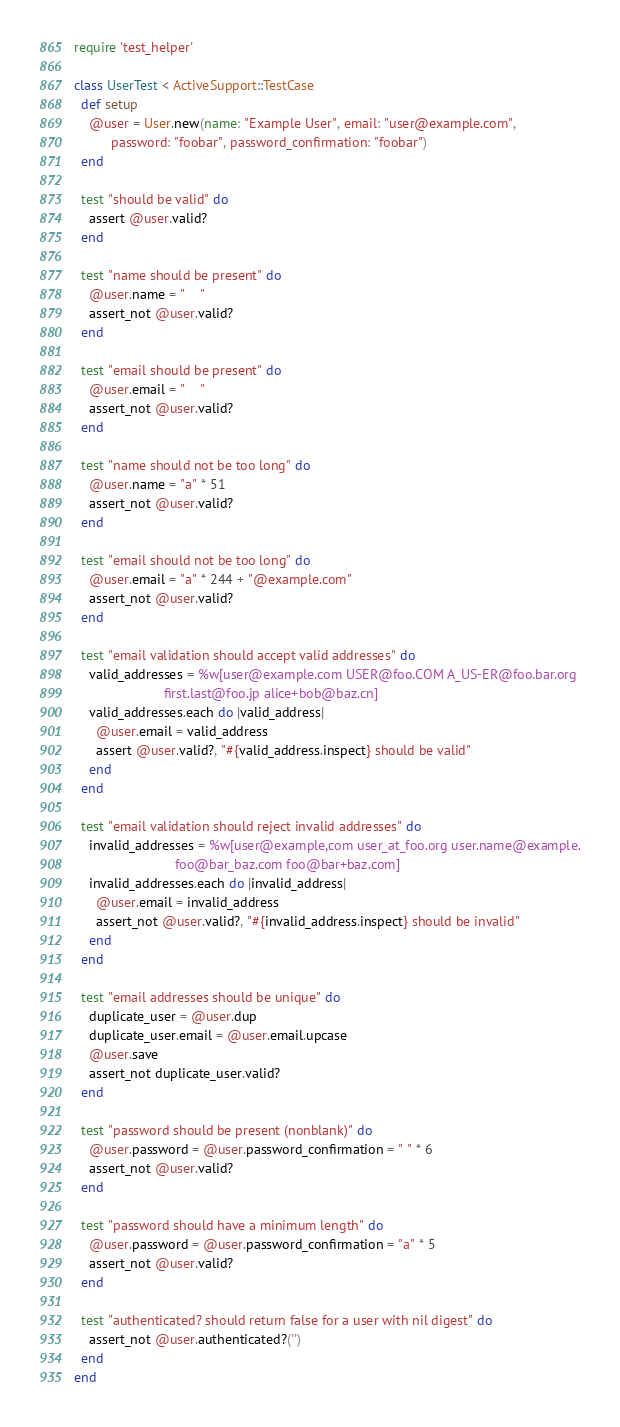Convert code to text. <code><loc_0><loc_0><loc_500><loc_500><_Ruby_>require 'test_helper'

class UserTest < ActiveSupport::TestCase
  def setup
    @user = User.new(name: "Example User", email: "user@example.com",
          password: "foobar", password_confirmation: "foobar")
  end

  test "should be valid" do
    assert @user.valid?
  end

  test "name should be present" do
    @user.name = "    "
    assert_not @user.valid?
  end

  test "email should be present" do
    @user.email = "    "
    assert_not @user.valid?
  end

  test "name should not be too long" do
    @user.name = "a" * 51
    assert_not @user.valid?
  end

  test "email should not be too long" do
    @user.email = "a" * 244 + "@example.com"
    assert_not @user.valid?
  end

  test "email validation should accept valid addresses" do
    valid_addresses = %w[user@example.com USER@foo.COM A_US-ER@foo.bar.org
                        first.last@foo.jp alice+bob@baz.cn]
    valid_addresses.each do |valid_address|
      @user.email = valid_address
      assert @user.valid?, "#{valid_address.inspect} should be valid"
    end
  end

  test "email validation should reject invalid addresses" do
    invalid_addresses = %w[user@example,com user_at_foo.org user.name@example.
                           foo@bar_baz.com foo@bar+baz.com]
    invalid_addresses.each do |invalid_address|
      @user.email = invalid_address
      assert_not @user.valid?, "#{invalid_address.inspect} should be invalid"
    end
  end

  test "email addresses should be unique" do
    duplicate_user = @user.dup
    duplicate_user.email = @user.email.upcase
    @user.save
    assert_not duplicate_user.valid?
  end

  test "password should be present (nonblank)" do
    @user.password = @user.password_confirmation = " " * 6
    assert_not @user.valid?
  end

  test "password should have a minimum length" do
    @user.password = @user.password_confirmation = "a" * 5
    assert_not @user.valid?
  end

  test "authenticated? should return false for a user with nil digest" do
    assert_not @user.authenticated?('')
  end
end
</code> 